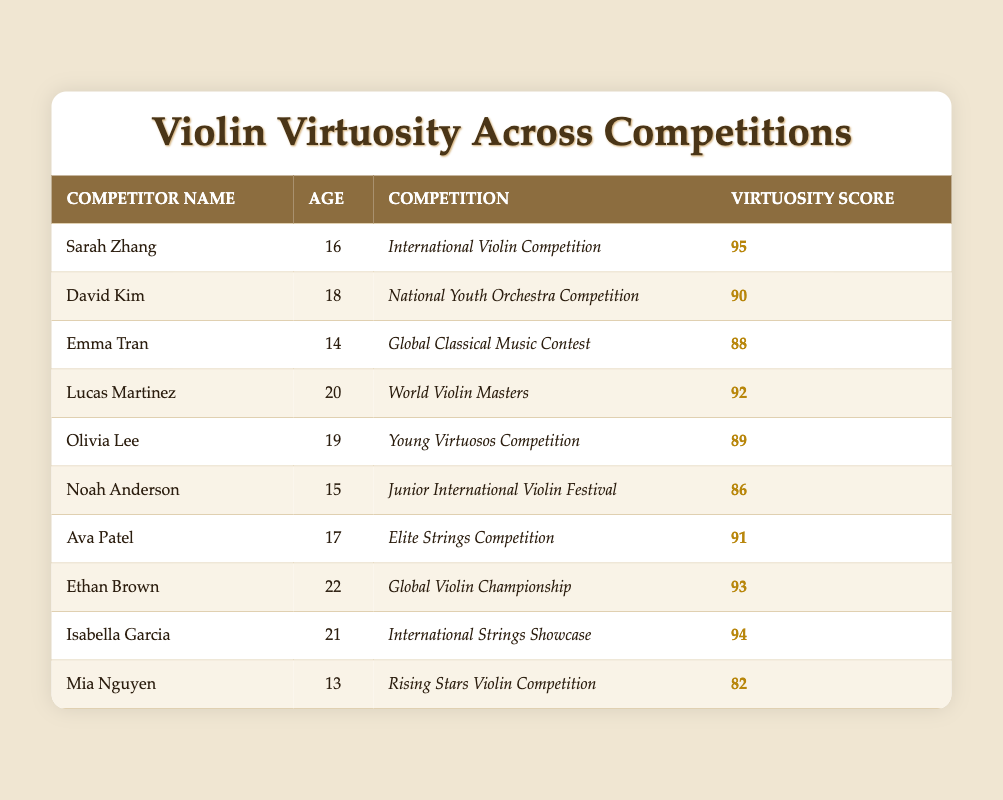What is the virtuosity score of Sarah Zhang? Sarah Zhang's virtuosity score is listed in the table under the "Virtuosity Score" column, where it shows a score of 95.
Answer: 95 How old is Noah Anderson? Noah Anderson's age is mentioned in the table under the "Age" column, which indicates that he is 15 years old.
Answer: 15 Which competitor has the highest virtuosity score? By examining the "Virtuosity Score" column, Sarah Zhang has the highest score of 95, making her the top competitor in terms of virtuosity.
Answer: Sarah Zhang What are the ages of the competitors who scored above 90? First, we identify competitors with scores above 90: Sarah Zhang (16), Ethan Brown (22), Isabella Garcia (21), and Lucas Martinez (20). Their ages are 16, 22, 21, and 20 respectively.
Answer: 16, 22, 21, 20 What is the average virtuosity score of all competitors? To find the average, we sum all the scores: (95 + 90 + 88 + 92 + 89 + 86 + 91 + 93 + 94 + 82) = 915. There are 10 competitors, so the average score is 915 / 10 = 91.5.
Answer: 91.5 Is there any competitor aged 14? By reviewing the "Age" column, Emma Tran is the only competitor listed as age 14.
Answer: Yes Which competitor, under 18, has the highest virtuosity score? We look at competitors under the age of 18: Sarah Zhang (16), David Kim (18), Emma Tran (14), and Noah Anderson (15). Among these, Sarah Zhang has the highest score of 95.
Answer: Sarah Zhang What is the difference in virtuosity scores between the youngest and oldest competitors? The youngest competitor is Mia Nguyen, with a score of 82, and the oldest is Ethan Brown, with a score of 93. The difference is calculated as 93 - 82 = 11.
Answer: 11 How many competitors scored less than 85? Checking the "Virtuosity Score" column, only Mia Nguyen with a score of 82 and Noah Anderson with a score of 86 fall below 85. There is only 1 competitor with a score less than 85.
Answer: 1 